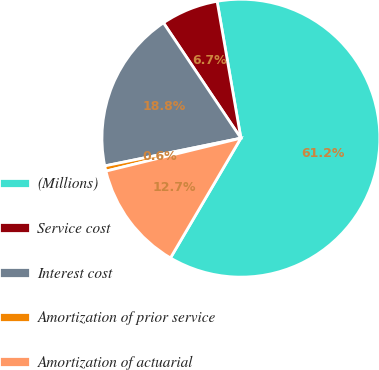<chart> <loc_0><loc_0><loc_500><loc_500><pie_chart><fcel>(Millions)<fcel>Service cost<fcel>Interest cost<fcel>Amortization of prior service<fcel>Amortization of actuarial<nl><fcel>61.2%<fcel>6.67%<fcel>18.79%<fcel>0.61%<fcel>12.73%<nl></chart> 